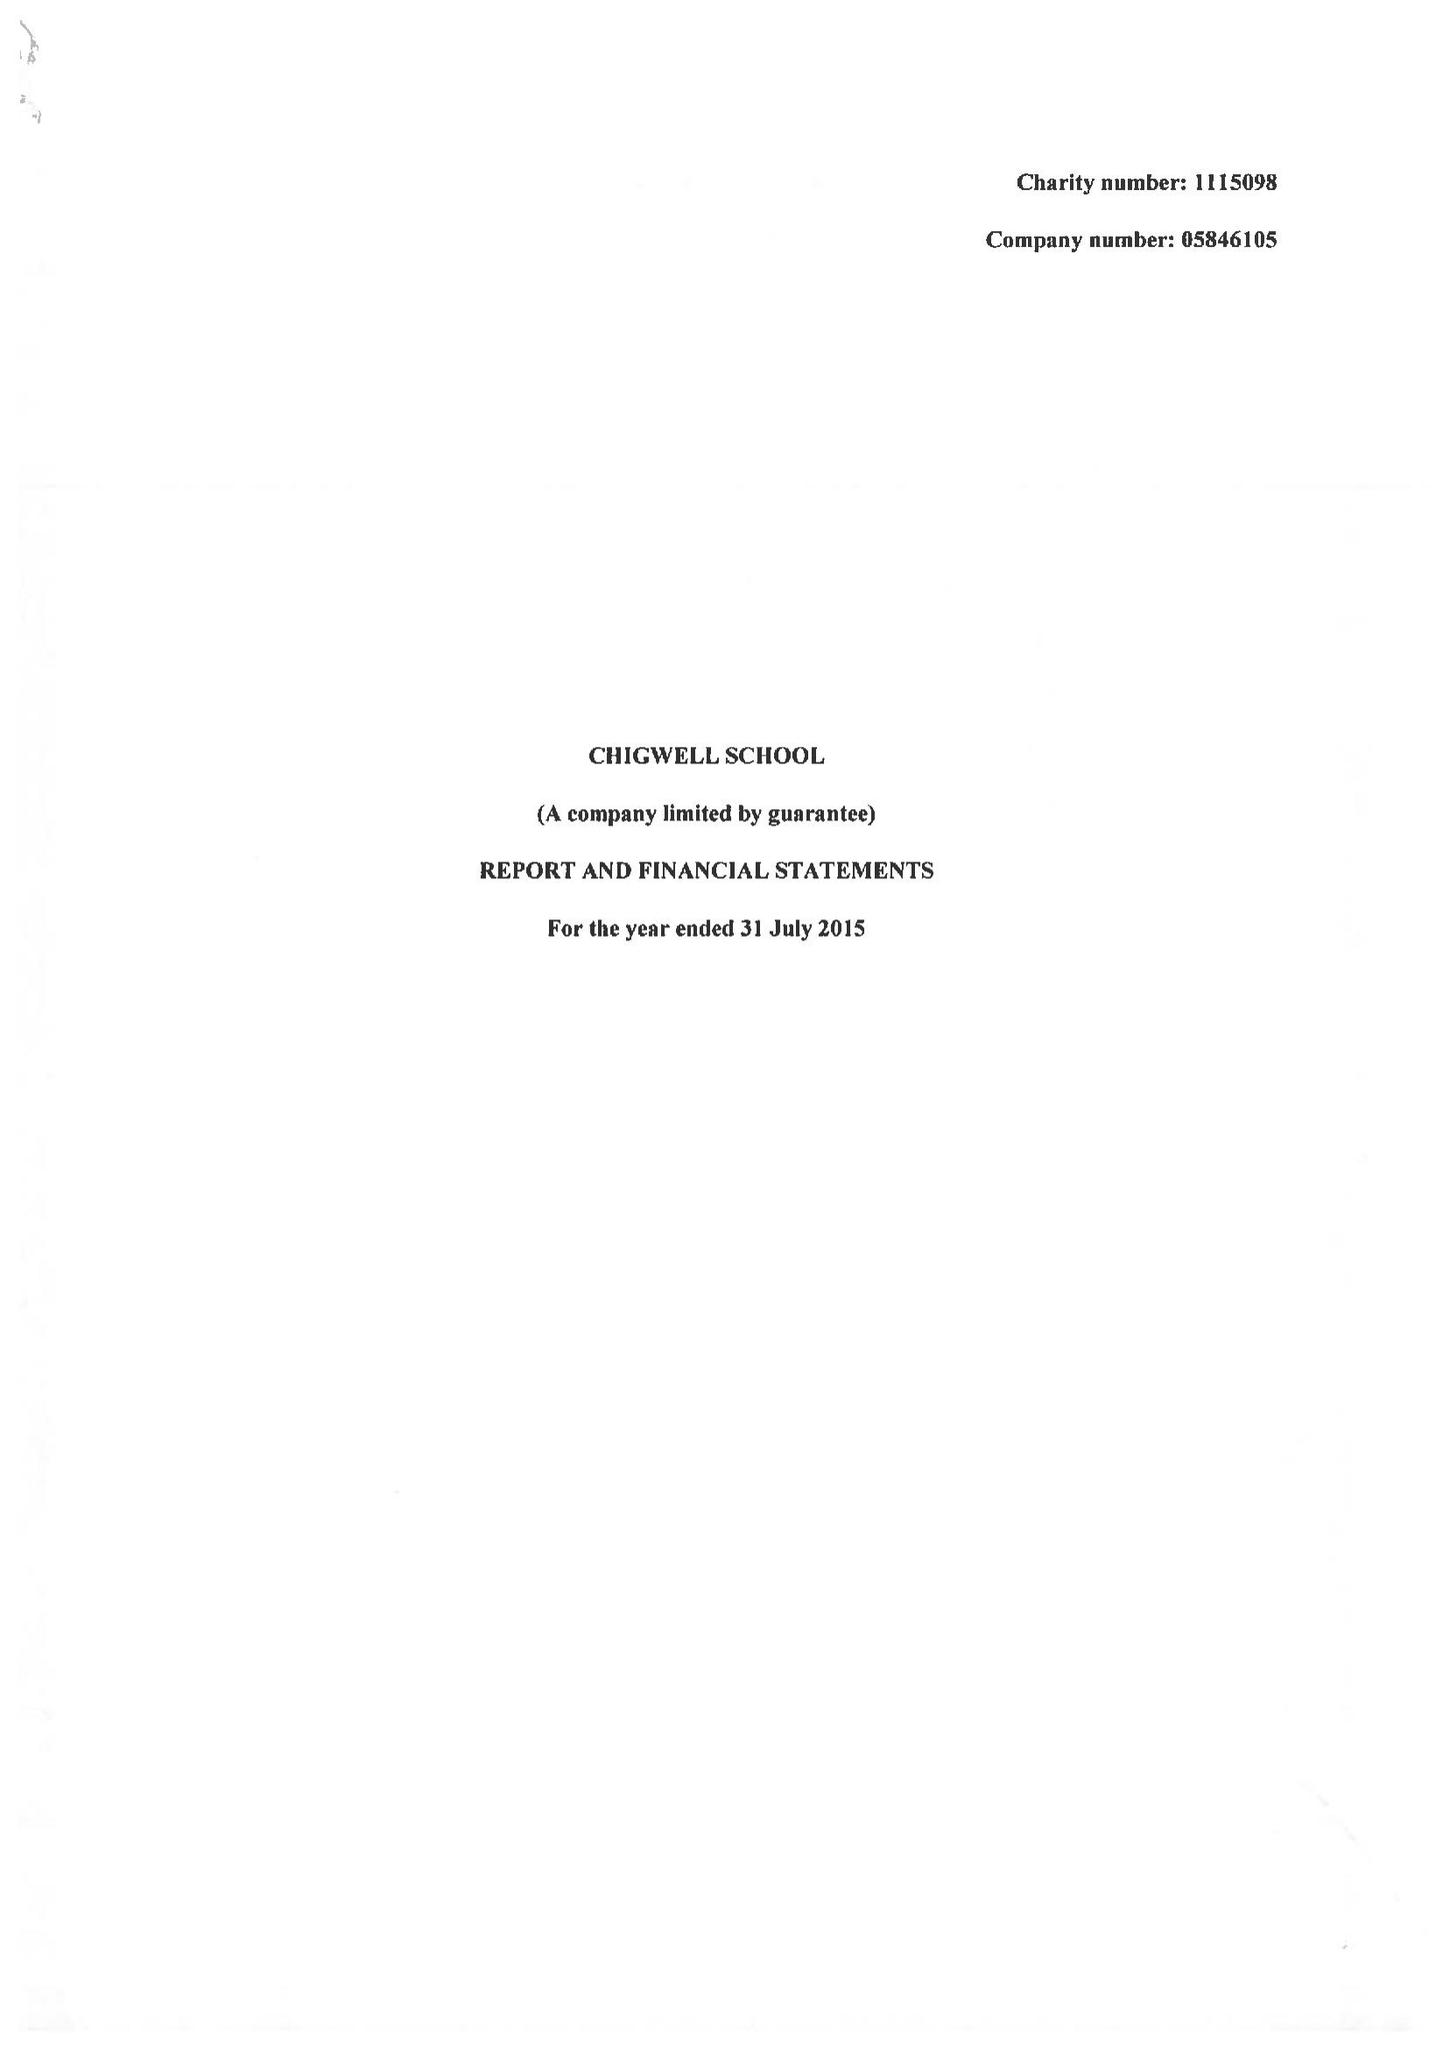What is the value for the spending_annually_in_british_pounds?
Answer the question using a single word or phrase. 10745000.00 